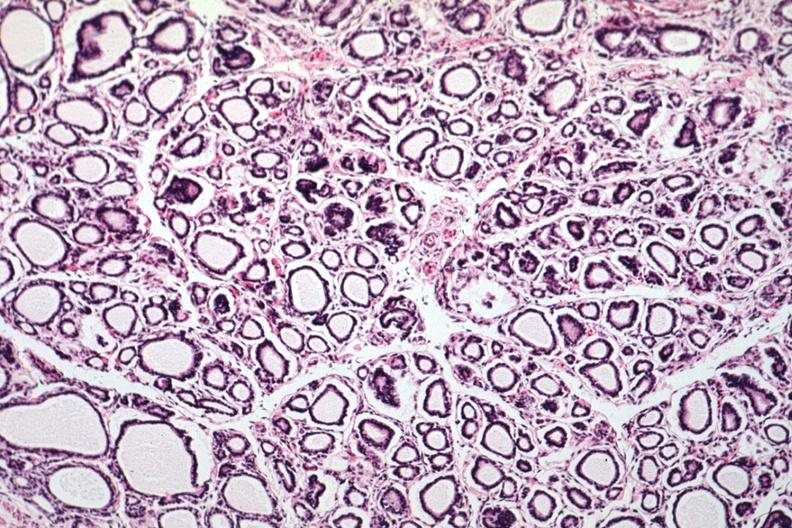what is present?
Answer the question using a single word or phrase. Normal immature infant 